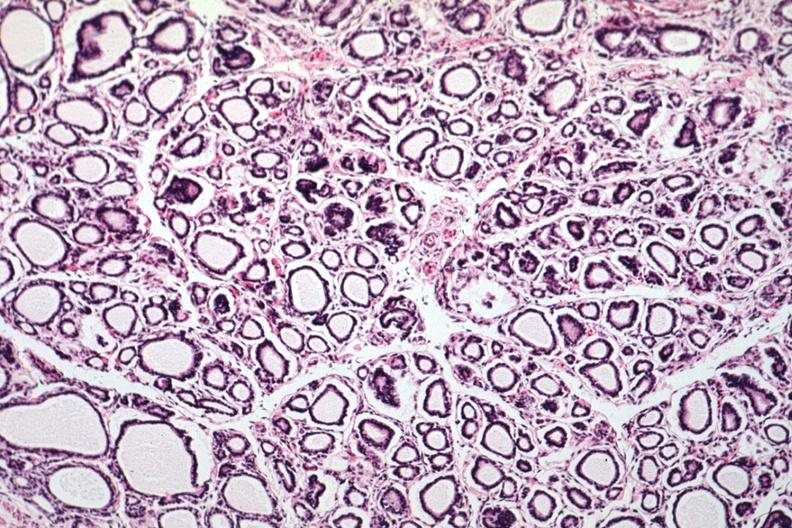what is present?
Answer the question using a single word or phrase. Normal immature infant 